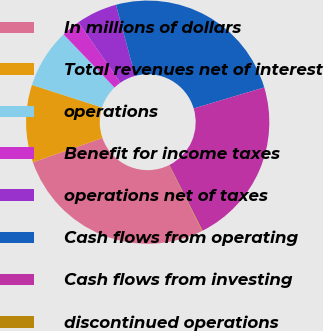Convert chart. <chart><loc_0><loc_0><loc_500><loc_500><pie_chart><fcel>In millions of dollars<fcel>Total revenues net of interest<fcel>operations<fcel>Benefit for income taxes<fcel>operations net of taxes<fcel>Cash flows from operating<fcel>Cash flows from investing<fcel>discontinued operations<nl><fcel>27.03%<fcel>10.31%<fcel>7.88%<fcel>2.51%<fcel>5.44%<fcel>24.6%<fcel>22.16%<fcel>0.07%<nl></chart> 